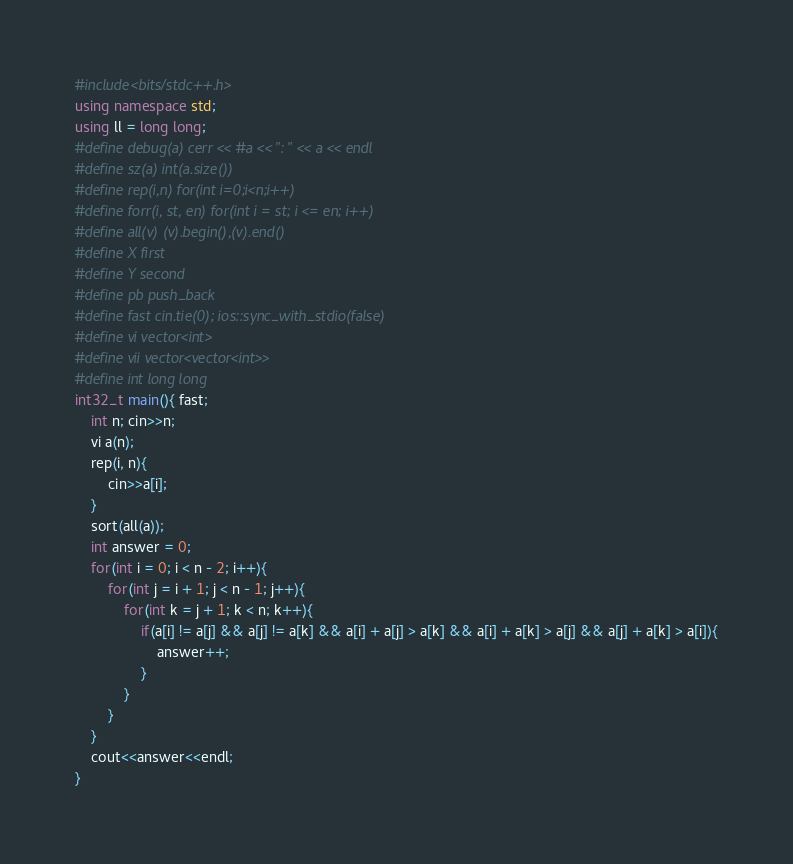Convert code to text. <code><loc_0><loc_0><loc_500><loc_500><_C++_>#include<bits/stdc++.h>
using namespace std;
using ll = long long;
#define debug(a) cerr << #a << ": " << a << endl
#define sz(a) int(a.size())
#define rep(i,n) for(int i=0;i<n;i++)
#define forr(i, st, en) for(int i = st; i <= en; i++)
#define all(v) (v).begin(),(v).end()
#define X first
#define Y second
#define pb push_back
#define fast cin.tie(0); ios::sync_with_stdio(false)
#define vi vector<int>
#define vii vector<vector<int>>
#define int long long
int32_t main(){ fast;
	int n; cin>>n;
	vi a(n);
	rep(i, n){
		cin>>a[i];
	}
	sort(all(a));
	int answer = 0;
	for(int i = 0; i < n - 2; i++){
		for(int j = i + 1; j < n - 1; j++){
			for(int k = j + 1; k < n; k++){
				if(a[i] != a[j] && a[j] != a[k] && a[i] + a[j] > a[k] && a[i] + a[k] > a[j] && a[j] + a[k] > a[i]){
					answer++;
				}
			}
		}
	}
	cout<<answer<<endl;
}
</code> 